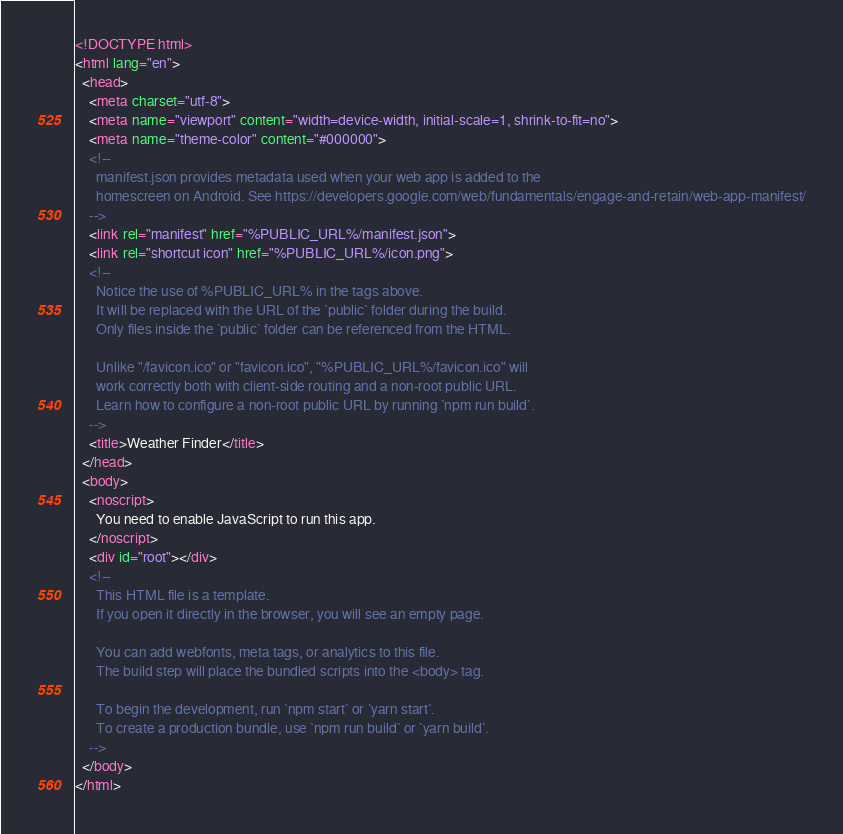<code> <loc_0><loc_0><loc_500><loc_500><_HTML_><!DOCTYPE html>
<html lang="en">
  <head>
    <meta charset="utf-8">
    <meta name="viewport" content="width=device-width, initial-scale=1, shrink-to-fit=no">
    <meta name="theme-color" content="#000000">
    <!--
      manifest.json provides metadata used when your web app is added to the
      homescreen on Android. See https://developers.google.com/web/fundamentals/engage-and-retain/web-app-manifest/
    -->
    <link rel="manifest" href="%PUBLIC_URL%/manifest.json">
    <link rel="shortcut icon" href="%PUBLIC_URL%/icon.png">
    <!--
      Notice the use of %PUBLIC_URL% in the tags above.
      It will be replaced with the URL of the `public` folder during the build.
      Only files inside the `public` folder can be referenced from the HTML.

      Unlike "/favicon.ico" or "favicon.ico", "%PUBLIC_URL%/favicon.ico" will
      work correctly both with client-side routing and a non-root public URL.
      Learn how to configure a non-root public URL by running `npm run build`.
    -->
    <title>Weather Finder</title>
  </head>
  <body>
    <noscript>
      You need to enable JavaScript to run this app.
    </noscript>
    <div id="root"></div>
    <!--
      This HTML file is a template.
      If you open it directly in the browser, you will see an empty page.

      You can add webfonts, meta tags, or analytics to this file.
      The build step will place the bundled scripts into the <body> tag.

      To begin the development, run `npm start` or `yarn start`.
      To create a production bundle, use `npm run build` or `yarn build`.
    -->
  </body>
</html>
</code> 